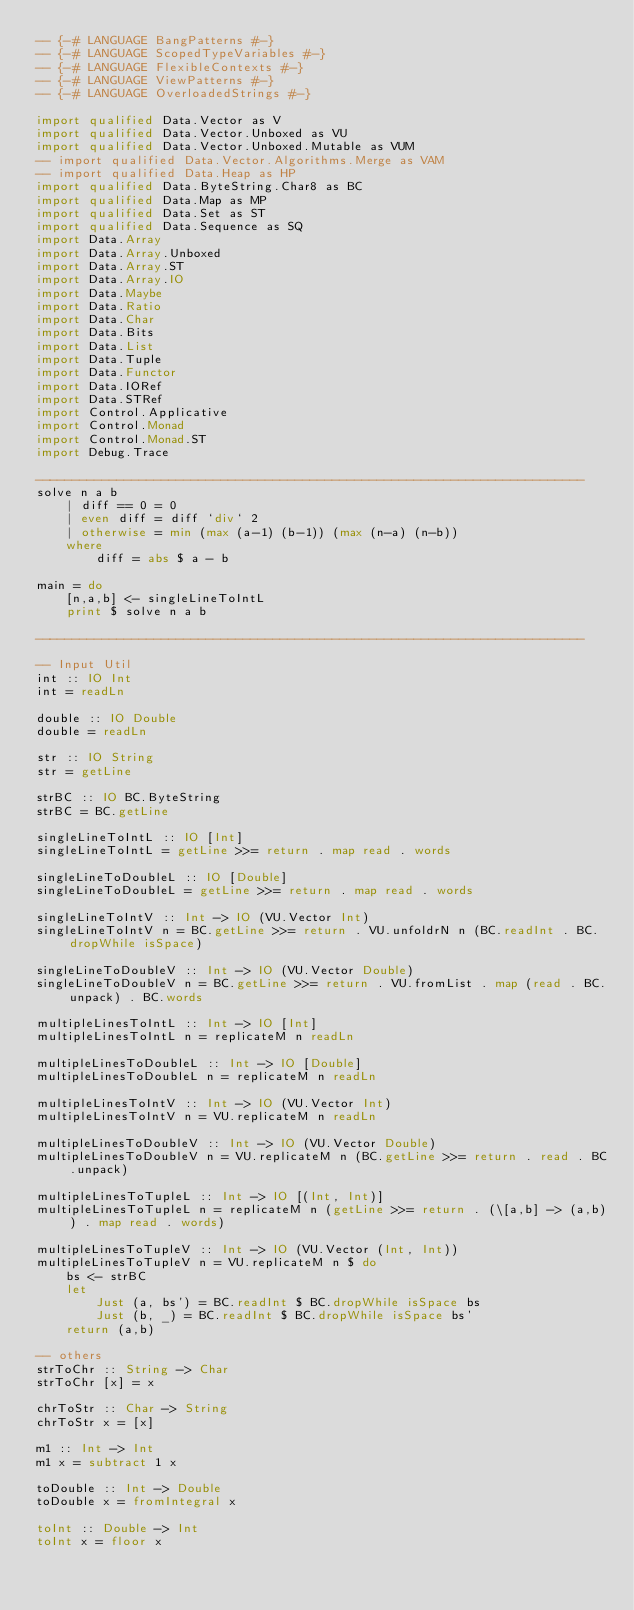Convert code to text. <code><loc_0><loc_0><loc_500><loc_500><_Haskell_>-- {-# LANGUAGE BangPatterns #-}
-- {-# LANGUAGE ScopedTypeVariables #-}
-- {-# LANGUAGE FlexibleContexts #-}
-- {-# LANGUAGE ViewPatterns #-}
-- {-# LANGUAGE OverloadedStrings #-}

import qualified Data.Vector as V
import qualified Data.Vector.Unboxed as VU
import qualified Data.Vector.Unboxed.Mutable as VUM
-- import qualified Data.Vector.Algorithms.Merge as VAM
-- import qualified Data.Heap as HP
import qualified Data.ByteString.Char8 as BC
import qualified Data.Map as MP
import qualified Data.Set as ST
import qualified Data.Sequence as SQ
import Data.Array
import Data.Array.Unboxed
import Data.Array.ST
import Data.Array.IO
import Data.Maybe
import Data.Ratio
import Data.Char
import Data.Bits
import Data.List
import Data.Tuple
import Data.Functor
import Data.IORef
import Data.STRef
import Control.Applicative
import Control.Monad
import Control.Monad.ST
import Debug.Trace

--------------------------------------------------------------------------
solve n a b
    | diff == 0 = 0
    | even diff = diff `div` 2
    | otherwise = min (max (a-1) (b-1)) (max (n-a) (n-b))
    where
        diff = abs $ a - b

main = do
    [n,a,b] <- singleLineToIntL 
    print $ solve n a b

--------------------------------------------------------------------------

-- Input Util
int :: IO Int
int = readLn 

double :: IO Double
double = readLn 

str :: IO String
str = getLine

strBC :: IO BC.ByteString
strBC = BC.getLine

singleLineToIntL :: IO [Int]
singleLineToIntL = getLine >>= return . map read . words

singleLineToDoubleL :: IO [Double]
singleLineToDoubleL = getLine >>= return . map read . words

singleLineToIntV :: Int -> IO (VU.Vector Int)
singleLineToIntV n = BC.getLine >>= return . VU.unfoldrN n (BC.readInt . BC.dropWhile isSpace)

singleLineToDoubleV :: Int -> IO (VU.Vector Double)
singleLineToDoubleV n = BC.getLine >>= return . VU.fromList . map (read . BC.unpack) . BC.words

multipleLinesToIntL :: Int -> IO [Int]
multipleLinesToIntL n = replicateM n readLn

multipleLinesToDoubleL :: Int -> IO [Double]
multipleLinesToDoubleL n = replicateM n readLn

multipleLinesToIntV :: Int -> IO (VU.Vector Int)
multipleLinesToIntV n = VU.replicateM n readLn

multipleLinesToDoubleV :: Int -> IO (VU.Vector Double)
multipleLinesToDoubleV n = VU.replicateM n (BC.getLine >>= return . read . BC.unpack)

multipleLinesToTupleL :: Int -> IO [(Int, Int)]
multipleLinesToTupleL n = replicateM n (getLine >>= return . (\[a,b] -> (a,b)) . map read . words)

multipleLinesToTupleV :: Int -> IO (VU.Vector (Int, Int))
multipleLinesToTupleV n = VU.replicateM n $ do
    bs <- strBC
    let
        Just (a, bs') = BC.readInt $ BC.dropWhile isSpace bs
        Just (b, _) = BC.readInt $ BC.dropWhile isSpace bs'
    return (a,b)

-- others
strToChr :: String -> Char
strToChr [x] = x

chrToStr :: Char -> String
chrToStr x = [x]

m1 :: Int -> Int
m1 x = subtract 1 x

toDouble :: Int -> Double
toDouble x = fromIntegral x

toInt :: Double -> Int
toInt x = floor x</code> 